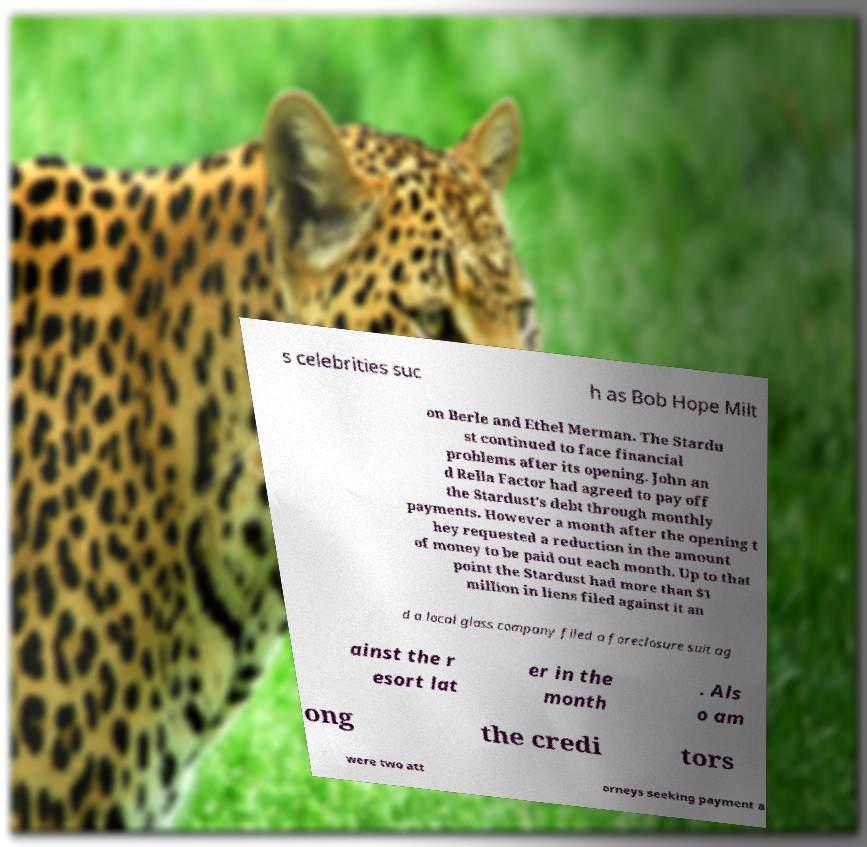Can you read and provide the text displayed in the image?This photo seems to have some interesting text. Can you extract and type it out for me? s celebrities suc h as Bob Hope Milt on Berle and Ethel Merman. The Stardu st continued to face financial problems after its opening. John an d Rella Factor had agreed to pay off the Stardust's debt through monthly payments. However a month after the opening t hey requested a reduction in the amount of money to be paid out each month. Up to that point the Stardust had more than $1 million in liens filed against it an d a local glass company filed a foreclosure suit ag ainst the r esort lat er in the month . Als o am ong the credi tors were two att orneys seeking payment a 